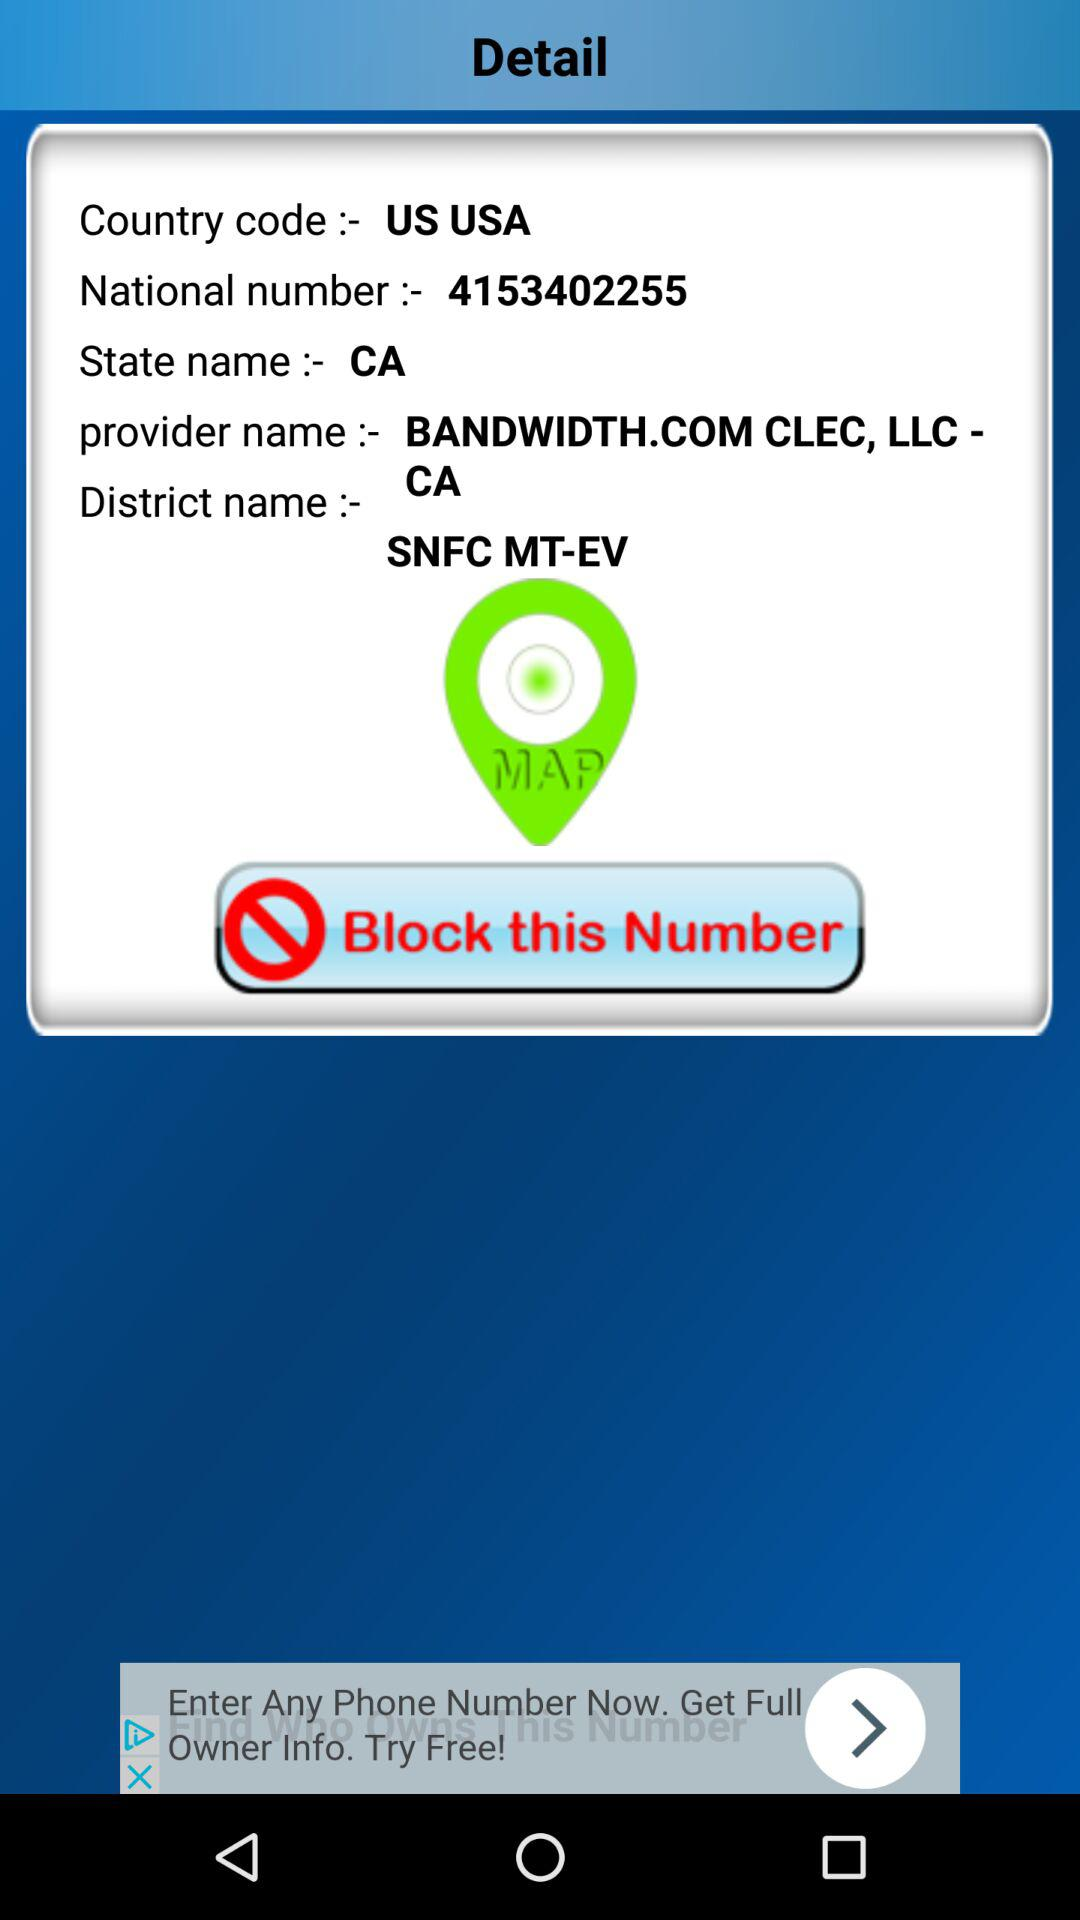What is the national number? The national number is 4153402255. 